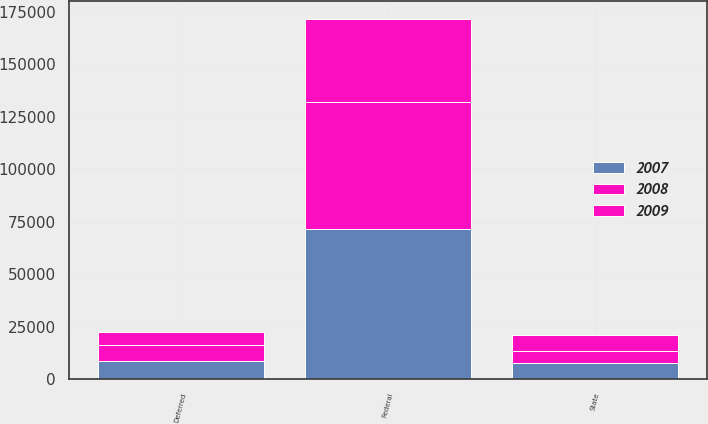Convert chart to OTSL. <chart><loc_0><loc_0><loc_500><loc_500><stacked_bar_chart><ecel><fcel>Federal<fcel>State<fcel>Deferred<nl><fcel>2007<fcel>71700<fcel>7600<fcel>8800<nl><fcel>2008<fcel>60190<fcel>5951<fcel>7335<nl><fcel>2009<fcel>39624<fcel>7572<fcel>6230<nl></chart> 